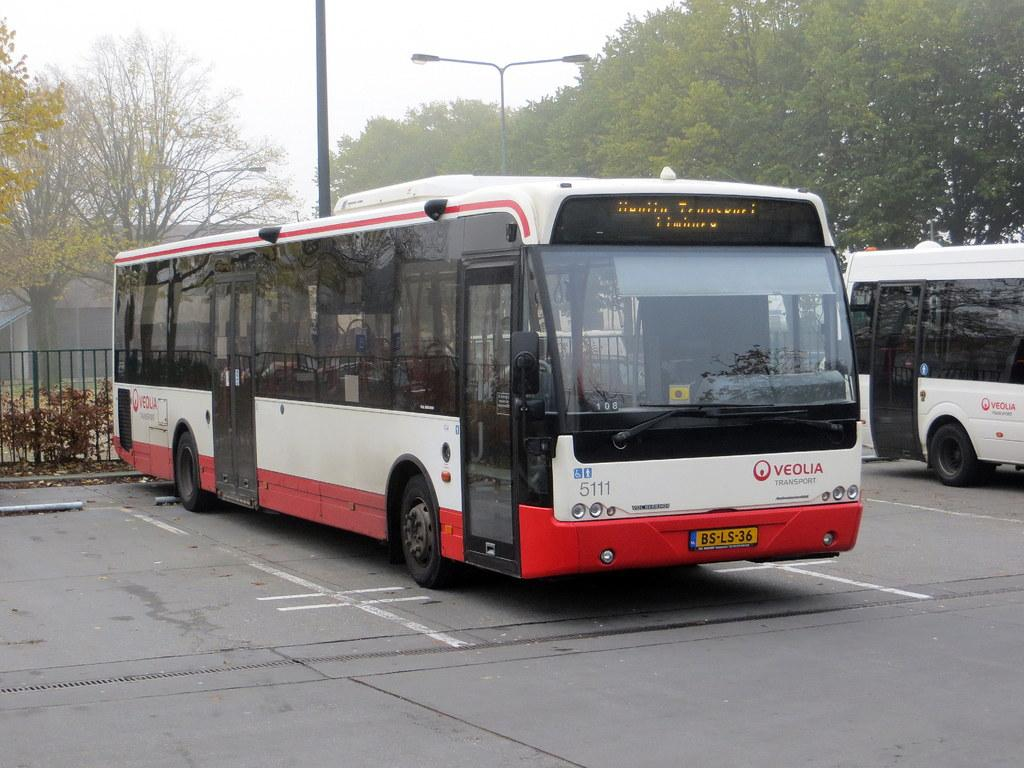<image>
Summarize the visual content of the image. A bus from Veolia Transport sits in a parking spot. 